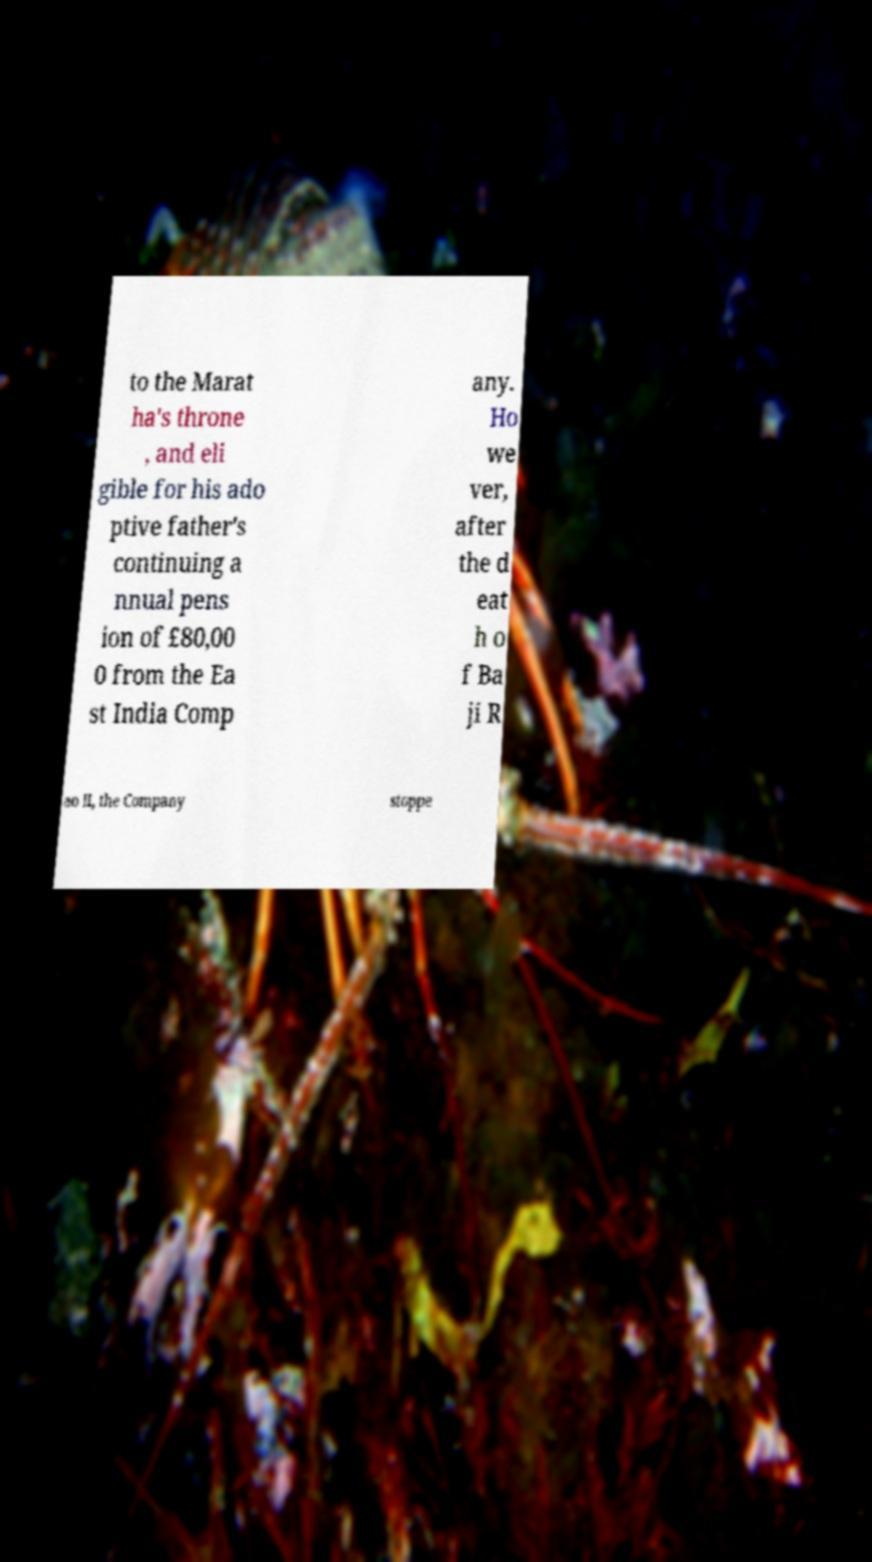Please read and relay the text visible in this image. What does it say? to the Marat ha's throne , and eli gible for his ado ptive father's continuing a nnual pens ion of £80,00 0 from the Ea st India Comp any. Ho we ver, after the d eat h o f Ba ji R ao II, the Company stoppe 